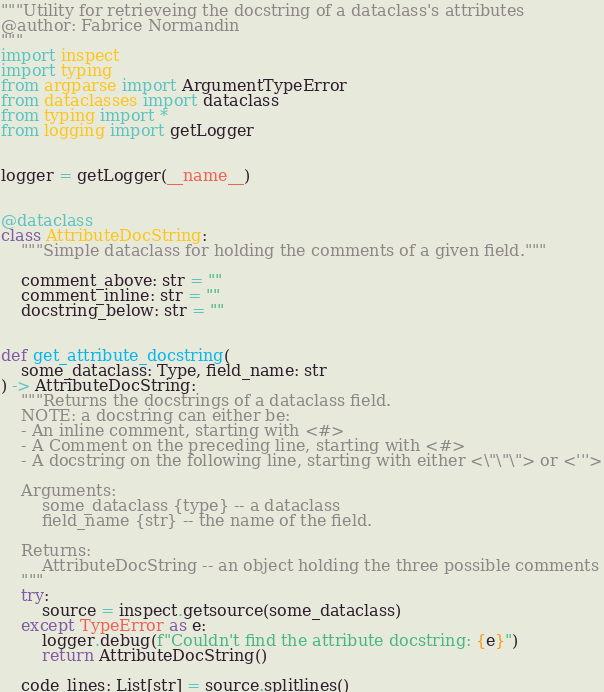<code> <loc_0><loc_0><loc_500><loc_500><_Python_>"""Utility for retrieveing the docstring of a dataclass's attributes
@author: Fabrice Normandin
"""
import inspect
import typing
from argparse import ArgumentTypeError
from dataclasses import dataclass
from typing import *
from logging import getLogger


logger = getLogger(__name__)


@dataclass
class AttributeDocString:
    """Simple dataclass for holding the comments of a given field."""

    comment_above: str = ""
    comment_inline: str = ""
    docstring_below: str = ""


def get_attribute_docstring(
    some_dataclass: Type, field_name: str
) -> AttributeDocString:
    """Returns the docstrings of a dataclass field.
    NOTE: a docstring can either be:
    - An inline comment, starting with <#>
    - A Comment on the preceding line, starting with <#>
    - A docstring on the following line, starting with either <\"\"\"> or <'''>

    Arguments:
        some_dataclass {type} -- a dataclass
        field_name {str} -- the name of the field.

    Returns:
        AttributeDocString -- an object holding the three possible comments
    """
    try:
        source = inspect.getsource(some_dataclass)
    except TypeError as e:
        logger.debug(f"Couldn't find the attribute docstring: {e}")
        return AttributeDocString()

    code_lines: List[str] = source.splitlines()</code> 